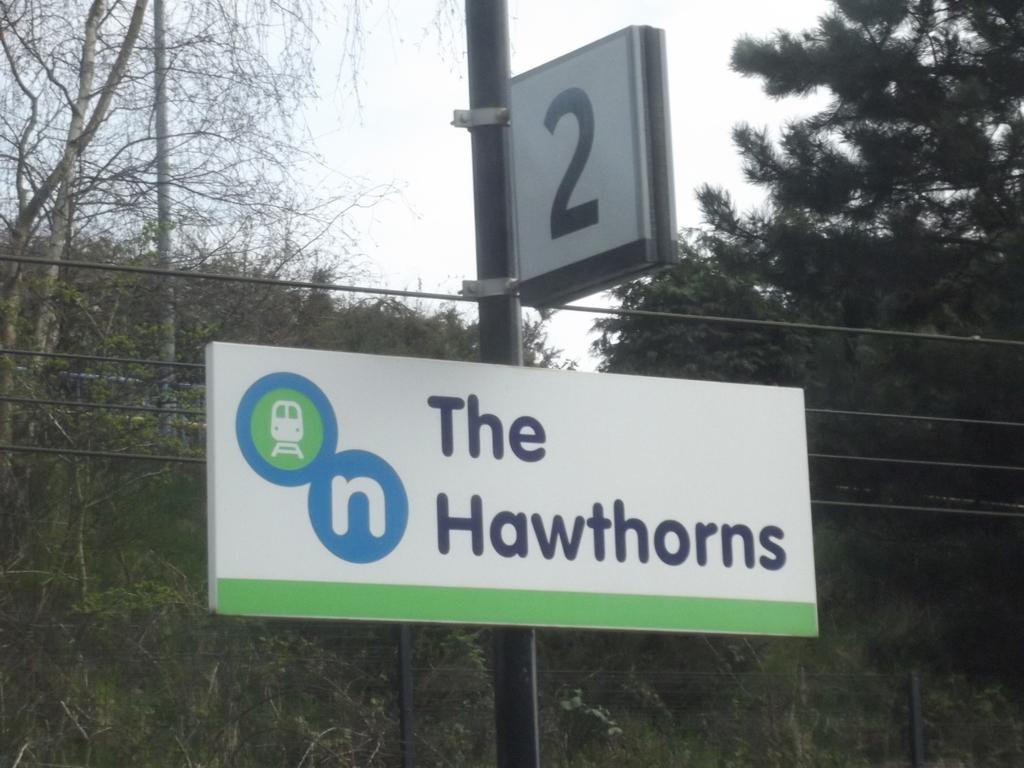<image>
Give a short and clear explanation of the subsequent image. A sign that says The Hawthorns on it. 